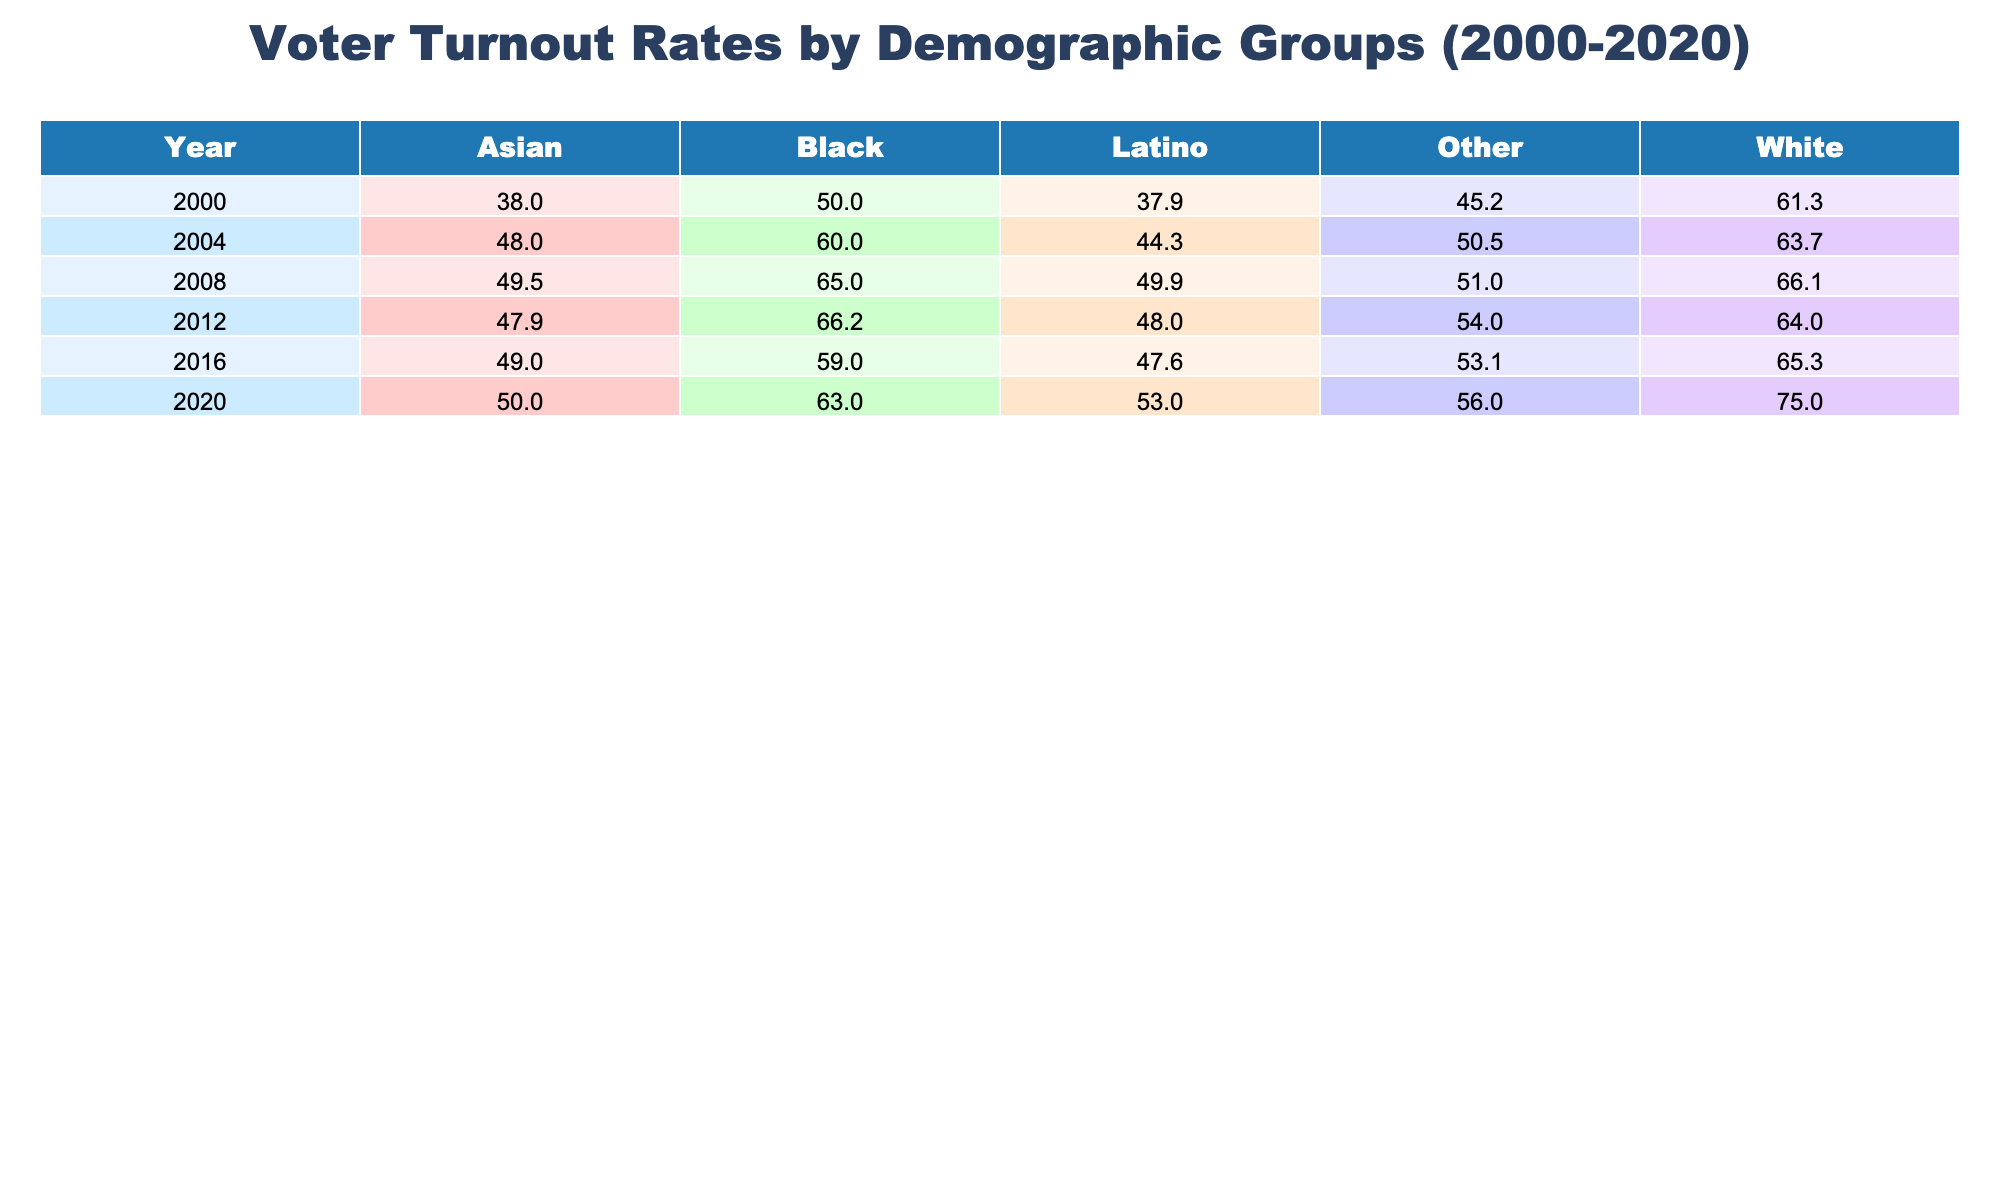What was the voter turnout rate for Black voters in the 2020 election? According to the table, the voter turnout rate for Black voters in the 2020 election is listed directly under the year 2020 in the Black voter row. The value is 63.0%.
Answer: 63.0 Which demographic group had the highest voter turnout in 2008? In the 2008 row, I compare the turnout rates across all demographic groups: White (66.1%), Black (65.0%), Latino (49.9%), Asian (49.5%), and Other (51.0%). The White demographic had the highest rate at 66.1%.
Answer: White What was the overall increase in Latino voter turnout from 2000 to 2020? For the years in question, I first determine the Latino voter turnout rates: 37.9% in 2000 and 53.0% in 2020. The increase is calculated as 53.0% - 37.9% = 15.1%.
Answer: 15.1 Did the voter turnout rate for White voters increase from 2016 to 2020? I look at the White voter turnout rates for both years: in 2016, it was 65.3%, and in 2020 it rose to 75.0%. Therefore, there was an increase, confirming that it did indeed rise.
Answer: Yes What is the average voter turnout rate for Asian voters from 2000 to 2020? I find the Asian voter turnout rates: 38.0%, 48.0%, 49.5%, 47.9%, 49.0%, and 50.0% over the years. I sum these values: (38 + 48 + 49.5 + 47.9 + 49 + 50) = 282.4. Then I divide by the number of entries (6) to get the average, which is 282.4 / 6 = 47.07%.
Answer: 47.07 What were the trends for Black voter turnout from 2000 to 2020? I observe the Black voter turnout rates: 50.0% in 2000, 60.0% in 2004, 65.0% in 2008, 66.2% in 2012, 59.0% in 2016, and 63.0% in 2020. The trend shows an overall increase from 2000 until 2012, a slight dip in 2016, then an increase again in 2020, indicating variability with an overall upward trend.
Answer: Increasing with variability Which demographic group showed the lowest turnout in 2012? I check the 2012 row for all demographic groups: White (64.0%), Black (66.2%), Latino (48.0%), Asian (47.9%), and Other (54.0%). The Latino group had the lowest turnout at 48.0%.
Answer: Latino If we compare the turnout rates of Other demographic from 2000 and 2020, what can we conclude? I find the rates: 45.2% in 2000 and 56.0% in 2020. This indicates an increase of 10.8% over the 20-year span, suggesting positive engagement trends among this group.
Answer: Increased by 10.8% 